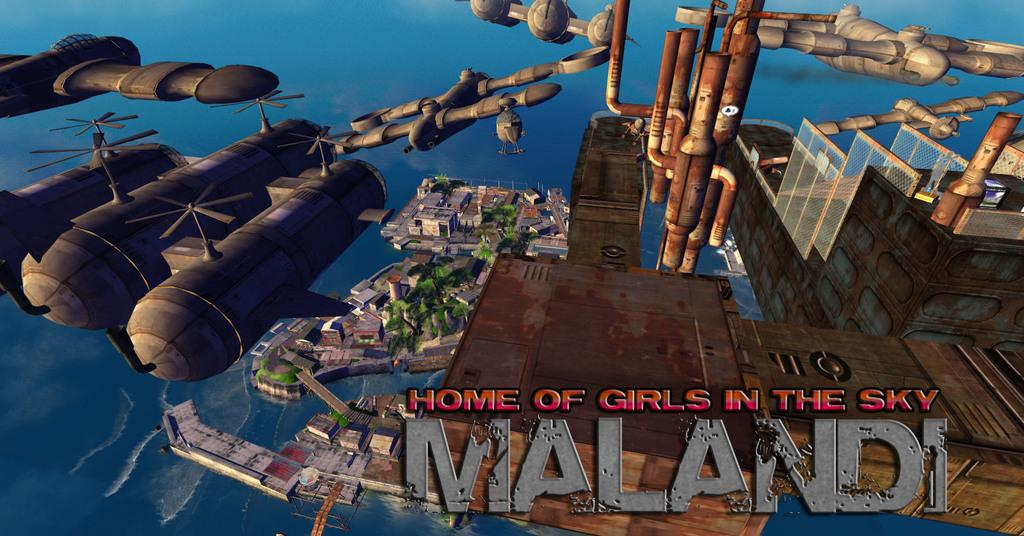What type of image is being described? The image is animated. What can be seen in the sky in the image? There are flying aircrafts in the image. What is visible in the background of the image? There are trees, buildings, and water visible in the background of the image. Is there any text present in the image? Yes, there is text at the bottom of the image. What type of oatmeal is being served to the friends in the image? There is no oatmeal or friends present in the image; it features flying aircrafts and a background with trees, buildings, and water. What type of destruction can be seen in the image? There is no destruction present in the image; it is an animated scene with flying aircrafts and a background with trees, buildings, and water. 